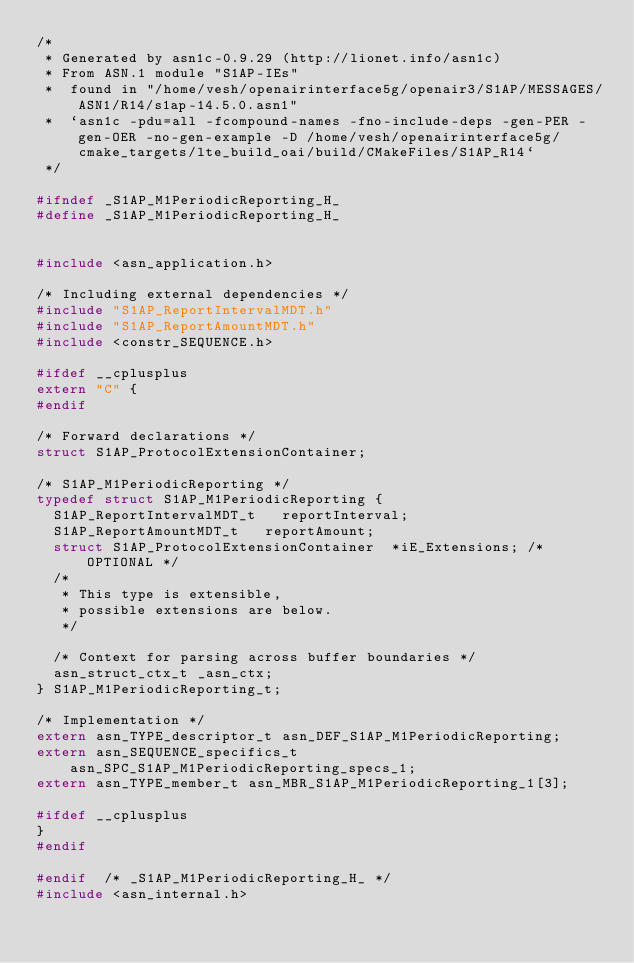Convert code to text. <code><loc_0><loc_0><loc_500><loc_500><_C_>/*
 * Generated by asn1c-0.9.29 (http://lionet.info/asn1c)
 * From ASN.1 module "S1AP-IEs"
 * 	found in "/home/vesh/openairinterface5g/openair3/S1AP/MESSAGES/ASN1/R14/s1ap-14.5.0.asn1"
 * 	`asn1c -pdu=all -fcompound-names -fno-include-deps -gen-PER -gen-OER -no-gen-example -D /home/vesh/openairinterface5g/cmake_targets/lte_build_oai/build/CMakeFiles/S1AP_R14`
 */

#ifndef	_S1AP_M1PeriodicReporting_H_
#define	_S1AP_M1PeriodicReporting_H_


#include <asn_application.h>

/* Including external dependencies */
#include "S1AP_ReportIntervalMDT.h"
#include "S1AP_ReportAmountMDT.h"
#include <constr_SEQUENCE.h>

#ifdef __cplusplus
extern "C" {
#endif

/* Forward declarations */
struct S1AP_ProtocolExtensionContainer;

/* S1AP_M1PeriodicReporting */
typedef struct S1AP_M1PeriodicReporting {
	S1AP_ReportIntervalMDT_t	 reportInterval;
	S1AP_ReportAmountMDT_t	 reportAmount;
	struct S1AP_ProtocolExtensionContainer	*iE_Extensions;	/* OPTIONAL */
	/*
	 * This type is extensible,
	 * possible extensions are below.
	 */
	
	/* Context for parsing across buffer boundaries */
	asn_struct_ctx_t _asn_ctx;
} S1AP_M1PeriodicReporting_t;

/* Implementation */
extern asn_TYPE_descriptor_t asn_DEF_S1AP_M1PeriodicReporting;
extern asn_SEQUENCE_specifics_t asn_SPC_S1AP_M1PeriodicReporting_specs_1;
extern asn_TYPE_member_t asn_MBR_S1AP_M1PeriodicReporting_1[3];

#ifdef __cplusplus
}
#endif

#endif	/* _S1AP_M1PeriodicReporting_H_ */
#include <asn_internal.h>
</code> 